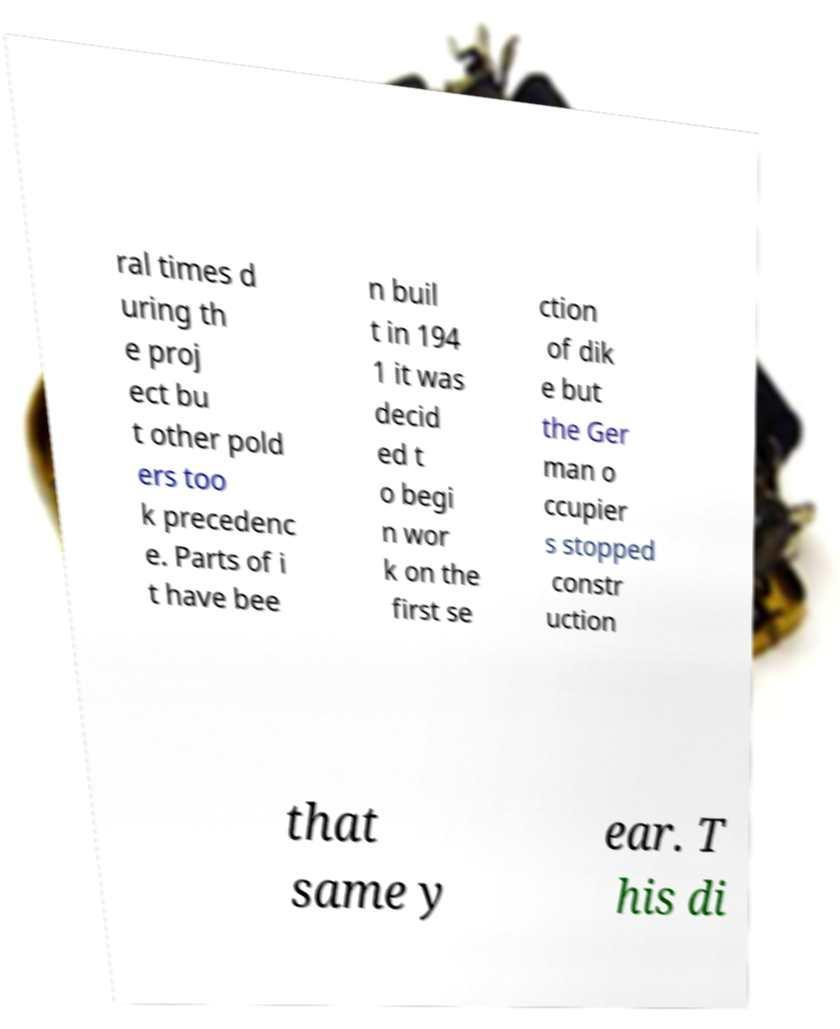Please identify and transcribe the text found in this image. ral times d uring th e proj ect bu t other pold ers too k precedenc e. Parts of i t have bee n buil t in 194 1 it was decid ed t o begi n wor k on the first se ction of dik e but the Ger man o ccupier s stopped constr uction that same y ear. T his di 